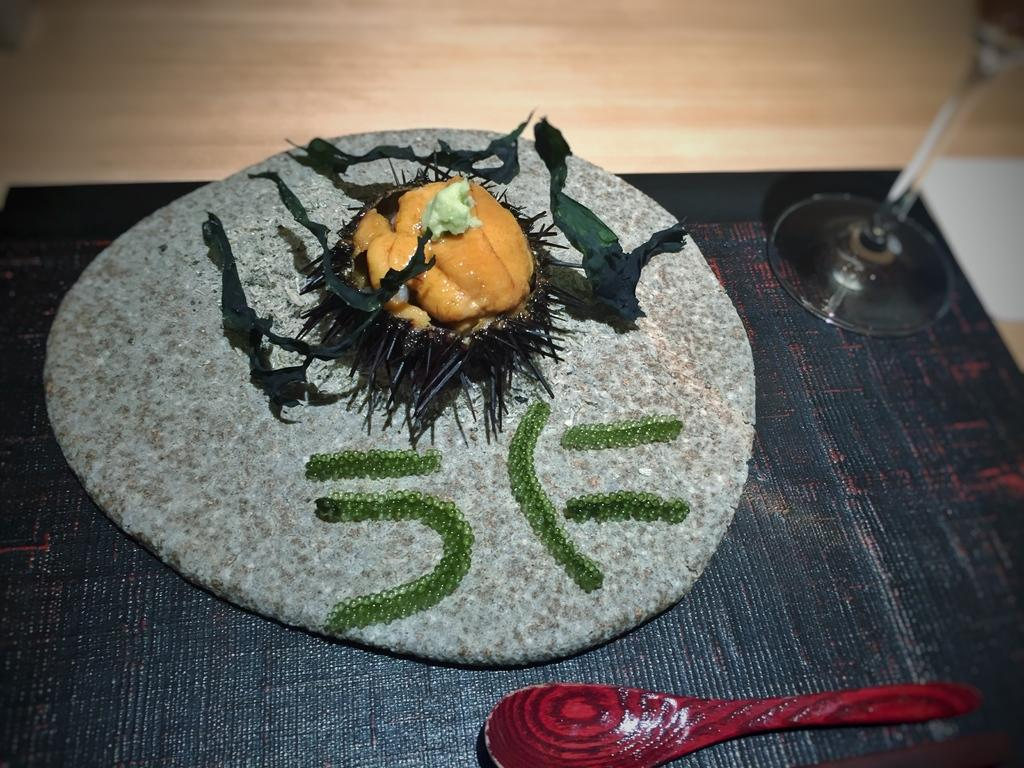What type of furniture is present in the image? There is a table in the image. What is placed on the table? There is a glass, a spoon, a tray, and food on the table. What is used to protect the table from spills or heat? There is a mat placed on the table. How does the bridge help the force of the food on the table? There is no bridge present in the image, and therefore no such interaction between a bridge and the food can be observed. 